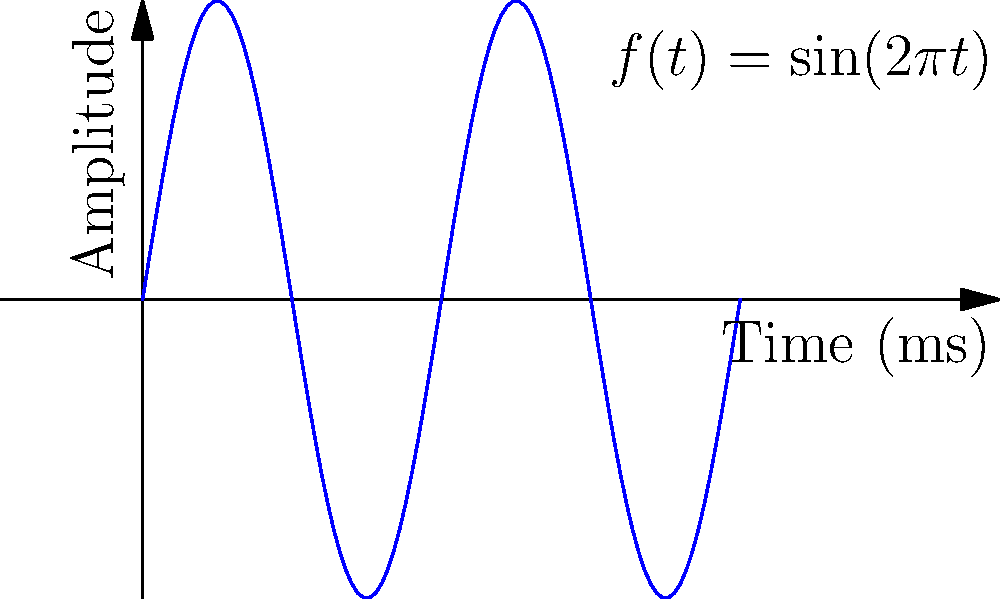As a database management specialist, you're tasked with optimizing network performance for a large-scale distributed database system. The network utilizes sine wave signals for data transmission. Given that the sine wave representing the signal is described by the function $f(t) = \sin(2\pi t)$, where $t$ is in milliseconds, calculate the maximum bandwidth (in Hz) that this network connection can support. To solve this problem, we need to follow these steps:

1) First, recall that the bandwidth is related to the frequency of the signal. In this case, we need to find the frequency of the given sine wave.

2) The general form of a sine wave is:
   $f(t) = A \sin(2\pi ft + \phi)$
   where $A$ is the amplitude, $f$ is the frequency, and $\phi$ is the phase shift.

3) Comparing our given function $f(t) = \sin(2\pi t)$ to the general form, we can see that:
   - The amplitude $A = 1$
   - The coefficient of $t$ inside the sine function is $2\pi$

4) In the general form, this coefficient represents $2\pi f$. So:
   $2\pi f = 2\pi$
   $f = 1$

5) This means the frequency is 1 cycle per millisecond.

6) To convert this to Hz (cycles per second), we need to multiply by 1000:
   $1 \text{ cycle}/\text{ms} \times 1000 \text{ ms}/\text{s} = 1000 \text{ Hz}$

7) Therefore, the maximum bandwidth this network connection can support is 1000 Hz or 1 kHz.
Answer: 1000 Hz 